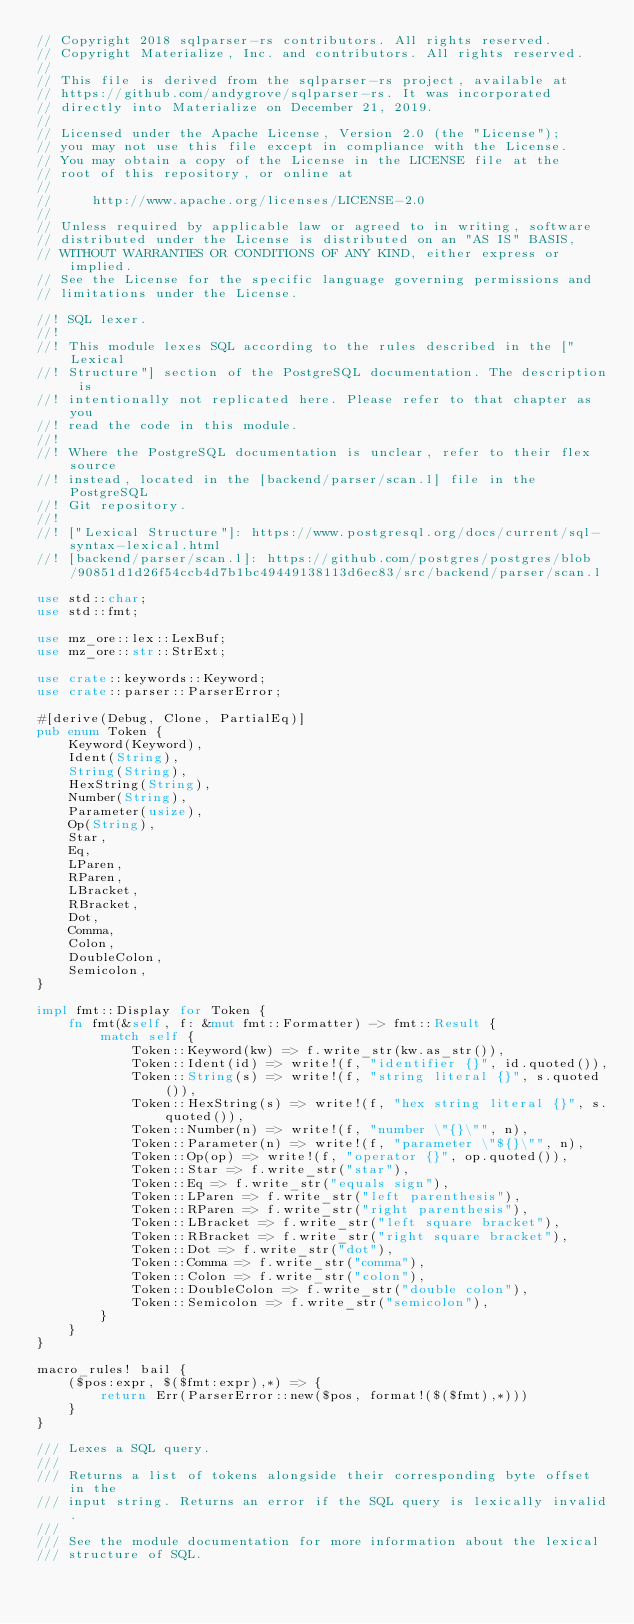<code> <loc_0><loc_0><loc_500><loc_500><_Rust_>// Copyright 2018 sqlparser-rs contributors. All rights reserved.
// Copyright Materialize, Inc. and contributors. All rights reserved.
//
// This file is derived from the sqlparser-rs project, available at
// https://github.com/andygrove/sqlparser-rs. It was incorporated
// directly into Materialize on December 21, 2019.
//
// Licensed under the Apache License, Version 2.0 (the "License");
// you may not use this file except in compliance with the License.
// You may obtain a copy of the License in the LICENSE file at the
// root of this repository, or online at
//
//     http://www.apache.org/licenses/LICENSE-2.0
//
// Unless required by applicable law or agreed to in writing, software
// distributed under the License is distributed on an "AS IS" BASIS,
// WITHOUT WARRANTIES OR CONDITIONS OF ANY KIND, either express or implied.
// See the License for the specific language governing permissions and
// limitations under the License.

//! SQL lexer.
//!
//! This module lexes SQL according to the rules described in the ["Lexical
//! Structure"] section of the PostgreSQL documentation. The description is
//! intentionally not replicated here. Please refer to that chapter as you
//! read the code in this module.
//!
//! Where the PostgreSQL documentation is unclear, refer to their flex source
//! instead, located in the [backend/parser/scan.l] file in the PostgreSQL
//! Git repository.
//!
//! ["Lexical Structure"]: https://www.postgresql.org/docs/current/sql-syntax-lexical.html
//! [backend/parser/scan.l]: https://github.com/postgres/postgres/blob/90851d1d26f54ccb4d7b1bc49449138113d6ec83/src/backend/parser/scan.l

use std::char;
use std::fmt;

use mz_ore::lex::LexBuf;
use mz_ore::str::StrExt;

use crate::keywords::Keyword;
use crate::parser::ParserError;

#[derive(Debug, Clone, PartialEq)]
pub enum Token {
    Keyword(Keyword),
    Ident(String),
    String(String),
    HexString(String),
    Number(String),
    Parameter(usize),
    Op(String),
    Star,
    Eq,
    LParen,
    RParen,
    LBracket,
    RBracket,
    Dot,
    Comma,
    Colon,
    DoubleColon,
    Semicolon,
}

impl fmt::Display for Token {
    fn fmt(&self, f: &mut fmt::Formatter) -> fmt::Result {
        match self {
            Token::Keyword(kw) => f.write_str(kw.as_str()),
            Token::Ident(id) => write!(f, "identifier {}", id.quoted()),
            Token::String(s) => write!(f, "string literal {}", s.quoted()),
            Token::HexString(s) => write!(f, "hex string literal {}", s.quoted()),
            Token::Number(n) => write!(f, "number \"{}\"", n),
            Token::Parameter(n) => write!(f, "parameter \"${}\"", n),
            Token::Op(op) => write!(f, "operator {}", op.quoted()),
            Token::Star => f.write_str("star"),
            Token::Eq => f.write_str("equals sign"),
            Token::LParen => f.write_str("left parenthesis"),
            Token::RParen => f.write_str("right parenthesis"),
            Token::LBracket => f.write_str("left square bracket"),
            Token::RBracket => f.write_str("right square bracket"),
            Token::Dot => f.write_str("dot"),
            Token::Comma => f.write_str("comma"),
            Token::Colon => f.write_str("colon"),
            Token::DoubleColon => f.write_str("double colon"),
            Token::Semicolon => f.write_str("semicolon"),
        }
    }
}

macro_rules! bail {
    ($pos:expr, $($fmt:expr),*) => {
        return Err(ParserError::new($pos, format!($($fmt),*)))
    }
}

/// Lexes a SQL query.
///
/// Returns a list of tokens alongside their corresponding byte offset in the
/// input string. Returns an error if the SQL query is lexically invalid.
///
/// See the module documentation for more information about the lexical
/// structure of SQL.</code> 